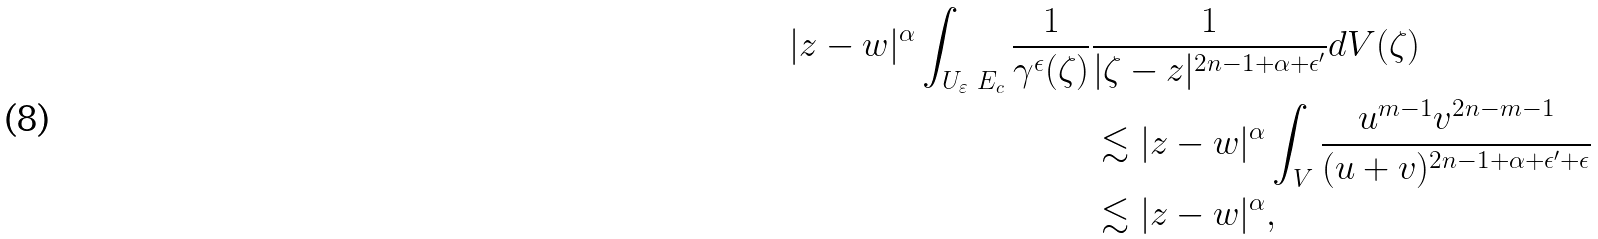Convert formula to latex. <formula><loc_0><loc_0><loc_500><loc_500>| z - w | ^ { \alpha } \int _ { U _ { \varepsilon } \ E _ { c } } \frac { 1 } { \gamma ^ { \epsilon } ( \zeta ) } & \frac { 1 } { | \zeta - z | ^ { 2 n - 1 + \alpha + \epsilon ^ { \prime } } } d V ( \zeta ) \\ & \lesssim | z - w | ^ { \alpha } \int _ { V } \frac { u ^ { m - 1 } v ^ { 2 n - m - 1 } } { ( u + v ) ^ { 2 n - 1 + \alpha + \epsilon ^ { \prime } + \epsilon } } \\ & \lesssim | z - w | ^ { \alpha } ,</formula> 